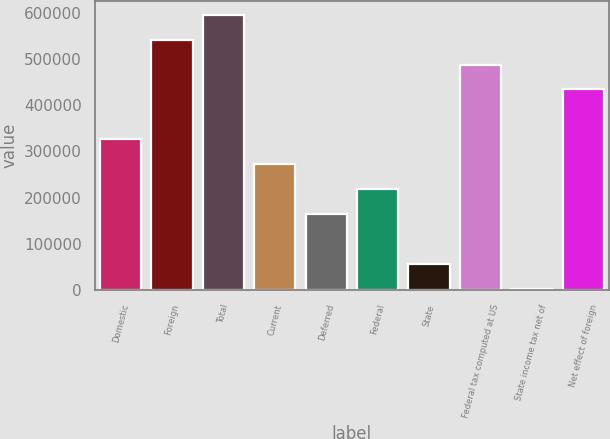<chart> <loc_0><loc_0><loc_500><loc_500><bar_chart><fcel>Domestic<fcel>Foreign<fcel>Total<fcel>Current<fcel>Deferred<fcel>Federal<fcel>State<fcel>Federal tax computed at US<fcel>State income tax net of<fcel>Net effect of foreign<nl><fcel>326192<fcel>541919<fcel>595851<fcel>272260<fcel>164396<fcel>218328<fcel>56532.8<fcel>487987<fcel>2601<fcel>434055<nl></chart> 